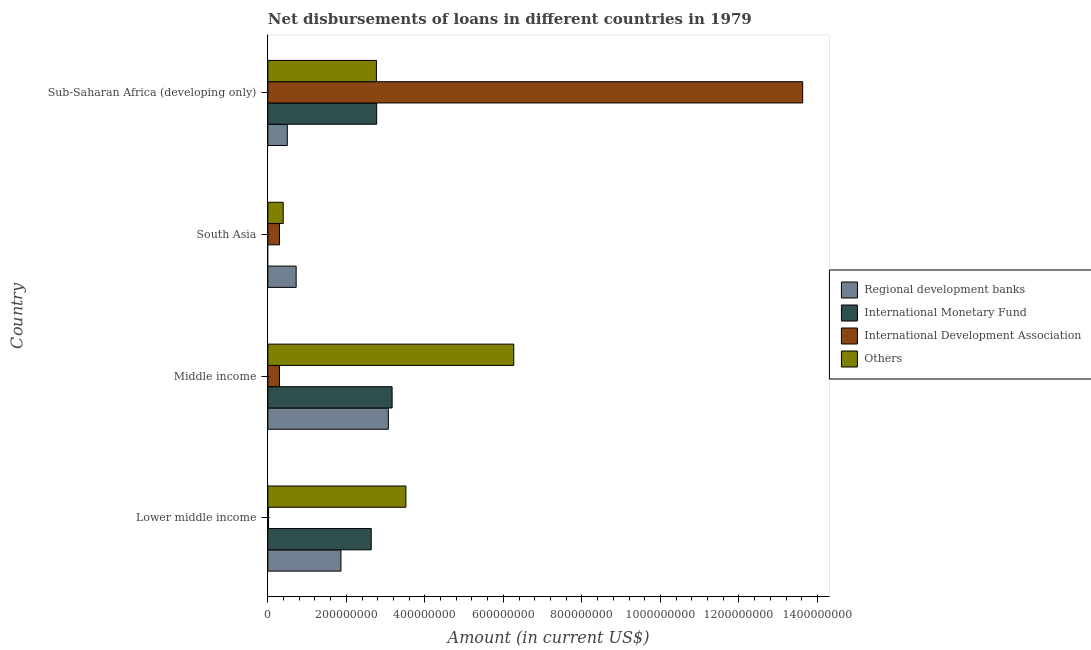How many groups of bars are there?
Provide a short and direct response. 4. Are the number of bars per tick equal to the number of legend labels?
Offer a very short reply. No. What is the label of the 4th group of bars from the top?
Your response must be concise. Lower middle income. In how many cases, is the number of bars for a given country not equal to the number of legend labels?
Provide a short and direct response. 1. What is the amount of loan disimbursed by international development association in Sub-Saharan Africa (developing only)?
Ensure brevity in your answer.  1.36e+09. Across all countries, what is the maximum amount of loan disimbursed by international monetary fund?
Offer a terse response. 3.17e+08. Across all countries, what is the minimum amount of loan disimbursed by other organisations?
Make the answer very short. 3.91e+07. What is the total amount of loan disimbursed by international development association in the graph?
Ensure brevity in your answer.  1.42e+09. What is the difference between the amount of loan disimbursed by other organisations in Lower middle income and that in Middle income?
Your answer should be compact. -2.75e+08. What is the difference between the amount of loan disimbursed by other organisations in South Asia and the amount of loan disimbursed by regional development banks in Lower middle income?
Your answer should be compact. -1.47e+08. What is the average amount of loan disimbursed by international monetary fund per country?
Make the answer very short. 2.14e+08. What is the difference between the amount of loan disimbursed by international monetary fund and amount of loan disimbursed by regional development banks in Lower middle income?
Your answer should be compact. 7.71e+07. In how many countries, is the amount of loan disimbursed by international development association greater than 1280000000 US$?
Your answer should be compact. 1. What is the ratio of the amount of loan disimbursed by international monetary fund in Lower middle income to that in Sub-Saharan Africa (developing only)?
Your answer should be very brief. 0.95. Is the difference between the amount of loan disimbursed by international development association in Lower middle income and Sub-Saharan Africa (developing only) greater than the difference between the amount of loan disimbursed by other organisations in Lower middle income and Sub-Saharan Africa (developing only)?
Provide a succinct answer. No. What is the difference between the highest and the second highest amount of loan disimbursed by international development association?
Your answer should be very brief. 1.33e+09. What is the difference between the highest and the lowest amount of loan disimbursed by regional development banks?
Offer a terse response. 2.57e+08. In how many countries, is the amount of loan disimbursed by international development association greater than the average amount of loan disimbursed by international development association taken over all countries?
Ensure brevity in your answer.  1. Is it the case that in every country, the sum of the amount of loan disimbursed by international monetary fund and amount of loan disimbursed by international development association is greater than the sum of amount of loan disimbursed by other organisations and amount of loan disimbursed by regional development banks?
Provide a succinct answer. No. How many bars are there?
Your answer should be compact. 15. Are all the bars in the graph horizontal?
Provide a short and direct response. Yes. Does the graph contain any zero values?
Provide a succinct answer. Yes. Does the graph contain grids?
Your response must be concise. No. Where does the legend appear in the graph?
Keep it short and to the point. Center right. What is the title of the graph?
Give a very brief answer. Net disbursements of loans in different countries in 1979. What is the label or title of the X-axis?
Offer a very short reply. Amount (in current US$). What is the label or title of the Y-axis?
Your answer should be very brief. Country. What is the Amount (in current US$) in Regional development banks in Lower middle income?
Give a very brief answer. 1.86e+08. What is the Amount (in current US$) of International Monetary Fund in Lower middle income?
Keep it short and to the point. 2.63e+08. What is the Amount (in current US$) in International Development Association in Lower middle income?
Provide a short and direct response. 1.83e+06. What is the Amount (in current US$) in Others in Lower middle income?
Keep it short and to the point. 3.52e+08. What is the Amount (in current US$) of Regional development banks in Middle income?
Keep it short and to the point. 3.07e+08. What is the Amount (in current US$) of International Monetary Fund in Middle income?
Give a very brief answer. 3.17e+08. What is the Amount (in current US$) in International Development Association in Middle income?
Give a very brief answer. 2.97e+07. What is the Amount (in current US$) of Others in Middle income?
Provide a short and direct response. 6.26e+08. What is the Amount (in current US$) of Regional development banks in South Asia?
Ensure brevity in your answer.  7.21e+07. What is the Amount (in current US$) in International Development Association in South Asia?
Ensure brevity in your answer.  2.97e+07. What is the Amount (in current US$) of Others in South Asia?
Offer a terse response. 3.91e+07. What is the Amount (in current US$) of Regional development banks in Sub-Saharan Africa (developing only)?
Your response must be concise. 4.96e+07. What is the Amount (in current US$) of International Monetary Fund in Sub-Saharan Africa (developing only)?
Keep it short and to the point. 2.77e+08. What is the Amount (in current US$) of International Development Association in Sub-Saharan Africa (developing only)?
Give a very brief answer. 1.36e+09. What is the Amount (in current US$) of Others in Sub-Saharan Africa (developing only)?
Give a very brief answer. 2.77e+08. Across all countries, what is the maximum Amount (in current US$) in Regional development banks?
Ensure brevity in your answer.  3.07e+08. Across all countries, what is the maximum Amount (in current US$) of International Monetary Fund?
Ensure brevity in your answer.  3.17e+08. Across all countries, what is the maximum Amount (in current US$) in International Development Association?
Offer a terse response. 1.36e+09. Across all countries, what is the maximum Amount (in current US$) in Others?
Keep it short and to the point. 6.26e+08. Across all countries, what is the minimum Amount (in current US$) in Regional development banks?
Provide a succinct answer. 4.96e+07. Across all countries, what is the minimum Amount (in current US$) of International Development Association?
Give a very brief answer. 1.83e+06. Across all countries, what is the minimum Amount (in current US$) of Others?
Provide a short and direct response. 3.91e+07. What is the total Amount (in current US$) of Regional development banks in the graph?
Your answer should be compact. 6.15e+08. What is the total Amount (in current US$) of International Monetary Fund in the graph?
Your answer should be very brief. 8.57e+08. What is the total Amount (in current US$) in International Development Association in the graph?
Keep it short and to the point. 1.42e+09. What is the total Amount (in current US$) of Others in the graph?
Provide a succinct answer. 1.29e+09. What is the difference between the Amount (in current US$) in Regional development banks in Lower middle income and that in Middle income?
Keep it short and to the point. -1.21e+08. What is the difference between the Amount (in current US$) of International Monetary Fund in Lower middle income and that in Middle income?
Provide a succinct answer. -5.32e+07. What is the difference between the Amount (in current US$) in International Development Association in Lower middle income and that in Middle income?
Provide a succinct answer. -2.79e+07. What is the difference between the Amount (in current US$) of Others in Lower middle income and that in Middle income?
Your answer should be compact. -2.75e+08. What is the difference between the Amount (in current US$) of Regional development banks in Lower middle income and that in South Asia?
Your answer should be very brief. 1.14e+08. What is the difference between the Amount (in current US$) of International Development Association in Lower middle income and that in South Asia?
Your response must be concise. -2.79e+07. What is the difference between the Amount (in current US$) of Others in Lower middle income and that in South Asia?
Your answer should be very brief. 3.13e+08. What is the difference between the Amount (in current US$) of Regional development banks in Lower middle income and that in Sub-Saharan Africa (developing only)?
Make the answer very short. 1.37e+08. What is the difference between the Amount (in current US$) of International Monetary Fund in Lower middle income and that in Sub-Saharan Africa (developing only)?
Ensure brevity in your answer.  -1.39e+07. What is the difference between the Amount (in current US$) in International Development Association in Lower middle income and that in Sub-Saharan Africa (developing only)?
Ensure brevity in your answer.  -1.36e+09. What is the difference between the Amount (in current US$) in Others in Lower middle income and that in Sub-Saharan Africa (developing only)?
Your answer should be compact. 7.51e+07. What is the difference between the Amount (in current US$) in Regional development banks in Middle income and that in South Asia?
Keep it short and to the point. 2.35e+08. What is the difference between the Amount (in current US$) in Others in Middle income and that in South Asia?
Provide a succinct answer. 5.87e+08. What is the difference between the Amount (in current US$) of Regional development banks in Middle income and that in Sub-Saharan Africa (developing only)?
Your answer should be compact. 2.57e+08. What is the difference between the Amount (in current US$) of International Monetary Fund in Middle income and that in Sub-Saharan Africa (developing only)?
Provide a short and direct response. 3.93e+07. What is the difference between the Amount (in current US$) in International Development Association in Middle income and that in Sub-Saharan Africa (developing only)?
Your answer should be compact. -1.33e+09. What is the difference between the Amount (in current US$) in Others in Middle income and that in Sub-Saharan Africa (developing only)?
Ensure brevity in your answer.  3.50e+08. What is the difference between the Amount (in current US$) of Regional development banks in South Asia and that in Sub-Saharan Africa (developing only)?
Keep it short and to the point. 2.25e+07. What is the difference between the Amount (in current US$) in International Development Association in South Asia and that in Sub-Saharan Africa (developing only)?
Your response must be concise. -1.33e+09. What is the difference between the Amount (in current US$) in Others in South Asia and that in Sub-Saharan Africa (developing only)?
Give a very brief answer. -2.37e+08. What is the difference between the Amount (in current US$) in Regional development banks in Lower middle income and the Amount (in current US$) in International Monetary Fund in Middle income?
Your response must be concise. -1.30e+08. What is the difference between the Amount (in current US$) of Regional development banks in Lower middle income and the Amount (in current US$) of International Development Association in Middle income?
Ensure brevity in your answer.  1.56e+08. What is the difference between the Amount (in current US$) of Regional development banks in Lower middle income and the Amount (in current US$) of Others in Middle income?
Your answer should be very brief. -4.40e+08. What is the difference between the Amount (in current US$) of International Monetary Fund in Lower middle income and the Amount (in current US$) of International Development Association in Middle income?
Your answer should be compact. 2.34e+08. What is the difference between the Amount (in current US$) of International Monetary Fund in Lower middle income and the Amount (in current US$) of Others in Middle income?
Your answer should be very brief. -3.63e+08. What is the difference between the Amount (in current US$) in International Development Association in Lower middle income and the Amount (in current US$) in Others in Middle income?
Ensure brevity in your answer.  -6.25e+08. What is the difference between the Amount (in current US$) of Regional development banks in Lower middle income and the Amount (in current US$) of International Development Association in South Asia?
Offer a very short reply. 1.56e+08. What is the difference between the Amount (in current US$) of Regional development banks in Lower middle income and the Amount (in current US$) of Others in South Asia?
Give a very brief answer. 1.47e+08. What is the difference between the Amount (in current US$) of International Monetary Fund in Lower middle income and the Amount (in current US$) of International Development Association in South Asia?
Your answer should be very brief. 2.34e+08. What is the difference between the Amount (in current US$) of International Monetary Fund in Lower middle income and the Amount (in current US$) of Others in South Asia?
Give a very brief answer. 2.24e+08. What is the difference between the Amount (in current US$) in International Development Association in Lower middle income and the Amount (in current US$) in Others in South Asia?
Provide a short and direct response. -3.73e+07. What is the difference between the Amount (in current US$) of Regional development banks in Lower middle income and the Amount (in current US$) of International Monetary Fund in Sub-Saharan Africa (developing only)?
Provide a short and direct response. -9.10e+07. What is the difference between the Amount (in current US$) in Regional development banks in Lower middle income and the Amount (in current US$) in International Development Association in Sub-Saharan Africa (developing only)?
Your answer should be very brief. -1.18e+09. What is the difference between the Amount (in current US$) in Regional development banks in Lower middle income and the Amount (in current US$) in Others in Sub-Saharan Africa (developing only)?
Make the answer very short. -9.04e+07. What is the difference between the Amount (in current US$) of International Monetary Fund in Lower middle income and the Amount (in current US$) of International Development Association in Sub-Saharan Africa (developing only)?
Give a very brief answer. -1.10e+09. What is the difference between the Amount (in current US$) in International Monetary Fund in Lower middle income and the Amount (in current US$) in Others in Sub-Saharan Africa (developing only)?
Provide a short and direct response. -1.33e+07. What is the difference between the Amount (in current US$) in International Development Association in Lower middle income and the Amount (in current US$) in Others in Sub-Saharan Africa (developing only)?
Offer a very short reply. -2.75e+08. What is the difference between the Amount (in current US$) in Regional development banks in Middle income and the Amount (in current US$) in International Development Association in South Asia?
Keep it short and to the point. 2.77e+08. What is the difference between the Amount (in current US$) in Regional development banks in Middle income and the Amount (in current US$) in Others in South Asia?
Offer a terse response. 2.68e+08. What is the difference between the Amount (in current US$) in International Monetary Fund in Middle income and the Amount (in current US$) in International Development Association in South Asia?
Provide a succinct answer. 2.87e+08. What is the difference between the Amount (in current US$) of International Monetary Fund in Middle income and the Amount (in current US$) of Others in South Asia?
Offer a terse response. 2.77e+08. What is the difference between the Amount (in current US$) in International Development Association in Middle income and the Amount (in current US$) in Others in South Asia?
Your response must be concise. -9.38e+06. What is the difference between the Amount (in current US$) of Regional development banks in Middle income and the Amount (in current US$) of International Monetary Fund in Sub-Saharan Africa (developing only)?
Provide a short and direct response. 2.97e+07. What is the difference between the Amount (in current US$) of Regional development banks in Middle income and the Amount (in current US$) of International Development Association in Sub-Saharan Africa (developing only)?
Provide a succinct answer. -1.06e+09. What is the difference between the Amount (in current US$) of Regional development banks in Middle income and the Amount (in current US$) of Others in Sub-Saharan Africa (developing only)?
Provide a succinct answer. 3.04e+07. What is the difference between the Amount (in current US$) of International Monetary Fund in Middle income and the Amount (in current US$) of International Development Association in Sub-Saharan Africa (developing only)?
Give a very brief answer. -1.05e+09. What is the difference between the Amount (in current US$) in International Monetary Fund in Middle income and the Amount (in current US$) in Others in Sub-Saharan Africa (developing only)?
Your answer should be compact. 4.00e+07. What is the difference between the Amount (in current US$) in International Development Association in Middle income and the Amount (in current US$) in Others in Sub-Saharan Africa (developing only)?
Your response must be concise. -2.47e+08. What is the difference between the Amount (in current US$) of Regional development banks in South Asia and the Amount (in current US$) of International Monetary Fund in Sub-Saharan Africa (developing only)?
Offer a very short reply. -2.05e+08. What is the difference between the Amount (in current US$) of Regional development banks in South Asia and the Amount (in current US$) of International Development Association in Sub-Saharan Africa (developing only)?
Ensure brevity in your answer.  -1.29e+09. What is the difference between the Amount (in current US$) of Regional development banks in South Asia and the Amount (in current US$) of Others in Sub-Saharan Africa (developing only)?
Make the answer very short. -2.04e+08. What is the difference between the Amount (in current US$) of International Development Association in South Asia and the Amount (in current US$) of Others in Sub-Saharan Africa (developing only)?
Offer a terse response. -2.47e+08. What is the average Amount (in current US$) in Regional development banks per country?
Offer a terse response. 1.54e+08. What is the average Amount (in current US$) in International Monetary Fund per country?
Ensure brevity in your answer.  2.14e+08. What is the average Amount (in current US$) of International Development Association per country?
Your answer should be very brief. 3.56e+08. What is the average Amount (in current US$) of Others per country?
Your response must be concise. 3.23e+08. What is the difference between the Amount (in current US$) in Regional development banks and Amount (in current US$) in International Monetary Fund in Lower middle income?
Give a very brief answer. -7.71e+07. What is the difference between the Amount (in current US$) of Regional development banks and Amount (in current US$) of International Development Association in Lower middle income?
Give a very brief answer. 1.84e+08. What is the difference between the Amount (in current US$) of Regional development banks and Amount (in current US$) of Others in Lower middle income?
Provide a short and direct response. -1.66e+08. What is the difference between the Amount (in current US$) of International Monetary Fund and Amount (in current US$) of International Development Association in Lower middle income?
Your answer should be compact. 2.61e+08. What is the difference between the Amount (in current US$) of International Monetary Fund and Amount (in current US$) of Others in Lower middle income?
Give a very brief answer. -8.84e+07. What is the difference between the Amount (in current US$) of International Development Association and Amount (in current US$) of Others in Lower middle income?
Ensure brevity in your answer.  -3.50e+08. What is the difference between the Amount (in current US$) in Regional development banks and Amount (in current US$) in International Monetary Fund in Middle income?
Ensure brevity in your answer.  -9.62e+06. What is the difference between the Amount (in current US$) in Regional development banks and Amount (in current US$) in International Development Association in Middle income?
Your answer should be compact. 2.77e+08. What is the difference between the Amount (in current US$) in Regional development banks and Amount (in current US$) in Others in Middle income?
Offer a terse response. -3.20e+08. What is the difference between the Amount (in current US$) in International Monetary Fund and Amount (in current US$) in International Development Association in Middle income?
Keep it short and to the point. 2.87e+08. What is the difference between the Amount (in current US$) in International Monetary Fund and Amount (in current US$) in Others in Middle income?
Your answer should be very brief. -3.10e+08. What is the difference between the Amount (in current US$) in International Development Association and Amount (in current US$) in Others in Middle income?
Your answer should be compact. -5.97e+08. What is the difference between the Amount (in current US$) in Regional development banks and Amount (in current US$) in International Development Association in South Asia?
Provide a short and direct response. 4.24e+07. What is the difference between the Amount (in current US$) of Regional development banks and Amount (in current US$) of Others in South Asia?
Make the answer very short. 3.30e+07. What is the difference between the Amount (in current US$) of International Development Association and Amount (in current US$) of Others in South Asia?
Offer a very short reply. -9.38e+06. What is the difference between the Amount (in current US$) in Regional development banks and Amount (in current US$) in International Monetary Fund in Sub-Saharan Africa (developing only)?
Give a very brief answer. -2.28e+08. What is the difference between the Amount (in current US$) of Regional development banks and Amount (in current US$) of International Development Association in Sub-Saharan Africa (developing only)?
Offer a terse response. -1.31e+09. What is the difference between the Amount (in current US$) in Regional development banks and Amount (in current US$) in Others in Sub-Saharan Africa (developing only)?
Give a very brief answer. -2.27e+08. What is the difference between the Amount (in current US$) of International Monetary Fund and Amount (in current US$) of International Development Association in Sub-Saharan Africa (developing only)?
Your response must be concise. -1.09e+09. What is the difference between the Amount (in current US$) in International Monetary Fund and Amount (in current US$) in Others in Sub-Saharan Africa (developing only)?
Offer a very short reply. 6.75e+05. What is the difference between the Amount (in current US$) of International Development Association and Amount (in current US$) of Others in Sub-Saharan Africa (developing only)?
Keep it short and to the point. 1.09e+09. What is the ratio of the Amount (in current US$) in Regional development banks in Lower middle income to that in Middle income?
Your response must be concise. 0.61. What is the ratio of the Amount (in current US$) in International Monetary Fund in Lower middle income to that in Middle income?
Your answer should be compact. 0.83. What is the ratio of the Amount (in current US$) in International Development Association in Lower middle income to that in Middle income?
Ensure brevity in your answer.  0.06. What is the ratio of the Amount (in current US$) in Others in Lower middle income to that in Middle income?
Offer a terse response. 0.56. What is the ratio of the Amount (in current US$) of Regional development banks in Lower middle income to that in South Asia?
Offer a very short reply. 2.58. What is the ratio of the Amount (in current US$) in International Development Association in Lower middle income to that in South Asia?
Offer a very short reply. 0.06. What is the ratio of the Amount (in current US$) of Others in Lower middle income to that in South Asia?
Your response must be concise. 9. What is the ratio of the Amount (in current US$) of Regional development banks in Lower middle income to that in Sub-Saharan Africa (developing only)?
Make the answer very short. 3.76. What is the ratio of the Amount (in current US$) in International Monetary Fund in Lower middle income to that in Sub-Saharan Africa (developing only)?
Provide a succinct answer. 0.95. What is the ratio of the Amount (in current US$) in International Development Association in Lower middle income to that in Sub-Saharan Africa (developing only)?
Offer a very short reply. 0. What is the ratio of the Amount (in current US$) of Others in Lower middle income to that in Sub-Saharan Africa (developing only)?
Offer a very short reply. 1.27. What is the ratio of the Amount (in current US$) in Regional development banks in Middle income to that in South Asia?
Offer a terse response. 4.26. What is the ratio of the Amount (in current US$) in Others in Middle income to that in South Asia?
Your answer should be very brief. 16.03. What is the ratio of the Amount (in current US$) in Regional development banks in Middle income to that in Sub-Saharan Africa (developing only)?
Your answer should be compact. 6.19. What is the ratio of the Amount (in current US$) of International Monetary Fund in Middle income to that in Sub-Saharan Africa (developing only)?
Your answer should be compact. 1.14. What is the ratio of the Amount (in current US$) of International Development Association in Middle income to that in Sub-Saharan Africa (developing only)?
Provide a succinct answer. 0.02. What is the ratio of the Amount (in current US$) in Others in Middle income to that in Sub-Saharan Africa (developing only)?
Your response must be concise. 2.27. What is the ratio of the Amount (in current US$) of Regional development banks in South Asia to that in Sub-Saharan Africa (developing only)?
Make the answer very short. 1.45. What is the ratio of the Amount (in current US$) in International Development Association in South Asia to that in Sub-Saharan Africa (developing only)?
Offer a very short reply. 0.02. What is the ratio of the Amount (in current US$) in Others in South Asia to that in Sub-Saharan Africa (developing only)?
Provide a succinct answer. 0.14. What is the difference between the highest and the second highest Amount (in current US$) of Regional development banks?
Your answer should be very brief. 1.21e+08. What is the difference between the highest and the second highest Amount (in current US$) of International Monetary Fund?
Make the answer very short. 3.93e+07. What is the difference between the highest and the second highest Amount (in current US$) in International Development Association?
Give a very brief answer. 1.33e+09. What is the difference between the highest and the second highest Amount (in current US$) of Others?
Offer a very short reply. 2.75e+08. What is the difference between the highest and the lowest Amount (in current US$) in Regional development banks?
Provide a short and direct response. 2.57e+08. What is the difference between the highest and the lowest Amount (in current US$) of International Monetary Fund?
Ensure brevity in your answer.  3.17e+08. What is the difference between the highest and the lowest Amount (in current US$) in International Development Association?
Your answer should be very brief. 1.36e+09. What is the difference between the highest and the lowest Amount (in current US$) of Others?
Offer a very short reply. 5.87e+08. 